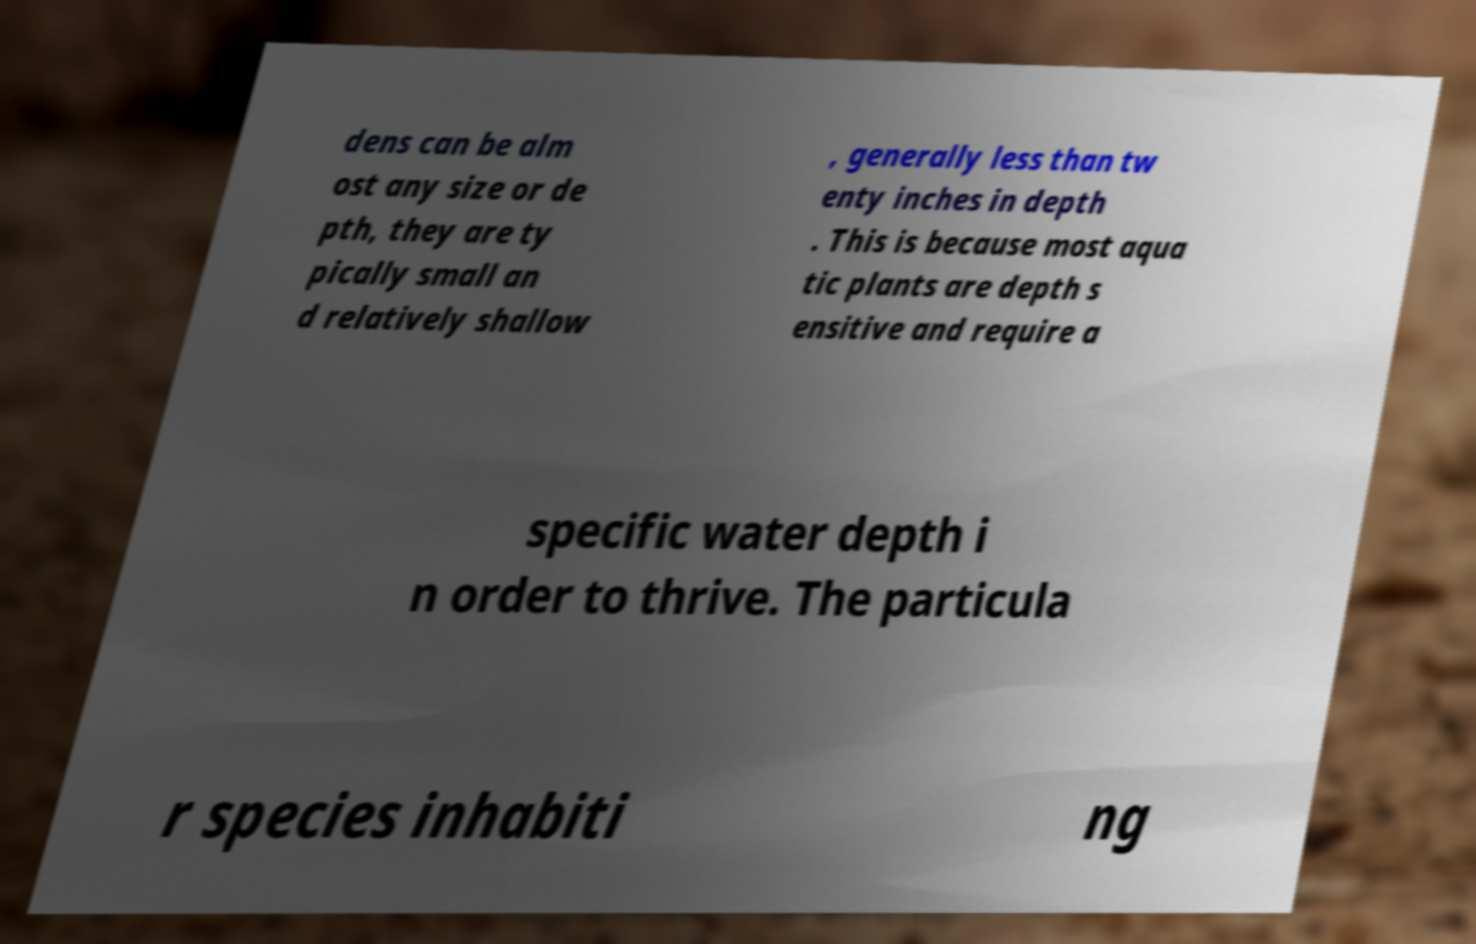Can you accurately transcribe the text from the provided image for me? dens can be alm ost any size or de pth, they are ty pically small an d relatively shallow , generally less than tw enty inches in depth . This is because most aqua tic plants are depth s ensitive and require a specific water depth i n order to thrive. The particula r species inhabiti ng 